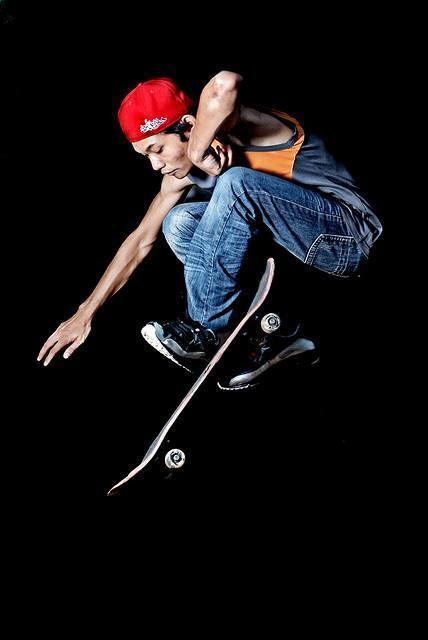How many microwaves are on the kitchen counter?
Give a very brief answer. 0. 